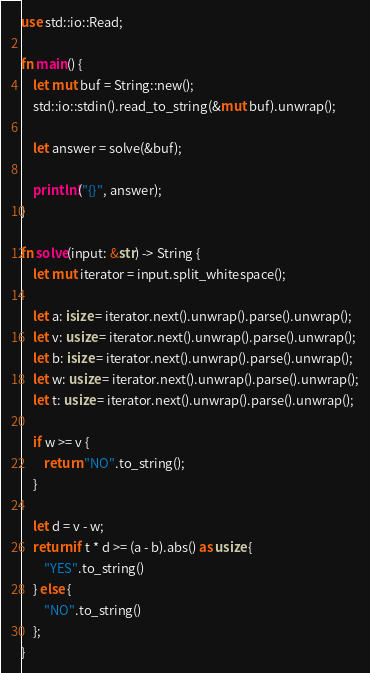<code> <loc_0><loc_0><loc_500><loc_500><_Rust_>use std::io::Read;

fn main() {
    let mut buf = String::new();
    std::io::stdin().read_to_string(&mut buf).unwrap();

    let answer = solve(&buf);

    println!("{}", answer);
}

fn solve(input: &str) -> String {
    let mut iterator = input.split_whitespace();

    let a: isize = iterator.next().unwrap().parse().unwrap();
    let v: usize = iterator.next().unwrap().parse().unwrap();
    let b: isize = iterator.next().unwrap().parse().unwrap();
    let w: usize = iterator.next().unwrap().parse().unwrap();
    let t: usize = iterator.next().unwrap().parse().unwrap();

    if w >= v {
        return "NO".to_string();
    }

    let d = v - w;
    return if t * d >= (a - b).abs() as usize {
        "YES".to_string()
    } else {
        "NO".to_string()
    };
}
</code> 